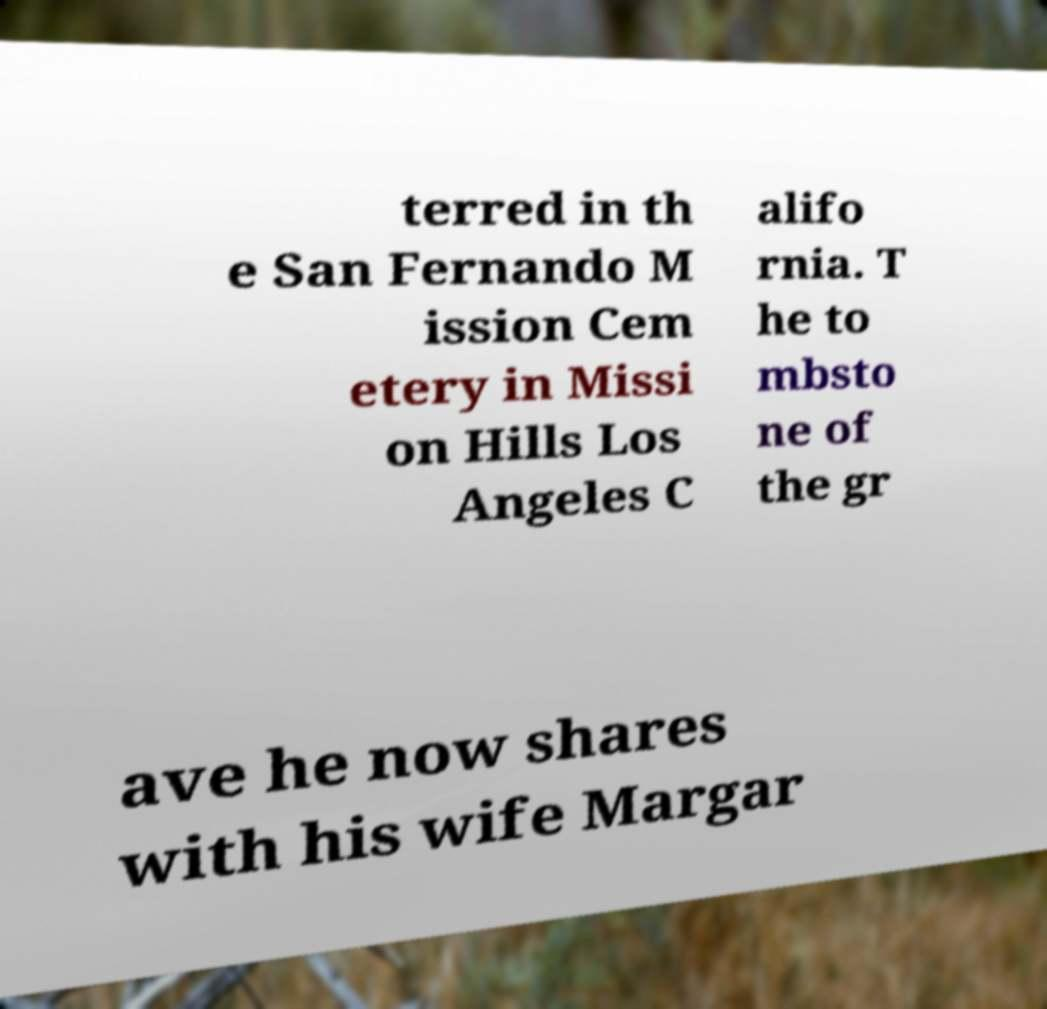Could you extract and type out the text from this image? terred in th e San Fernando M ission Cem etery in Missi on Hills Los Angeles C alifo rnia. T he to mbsto ne of the gr ave he now shares with his wife Margar 